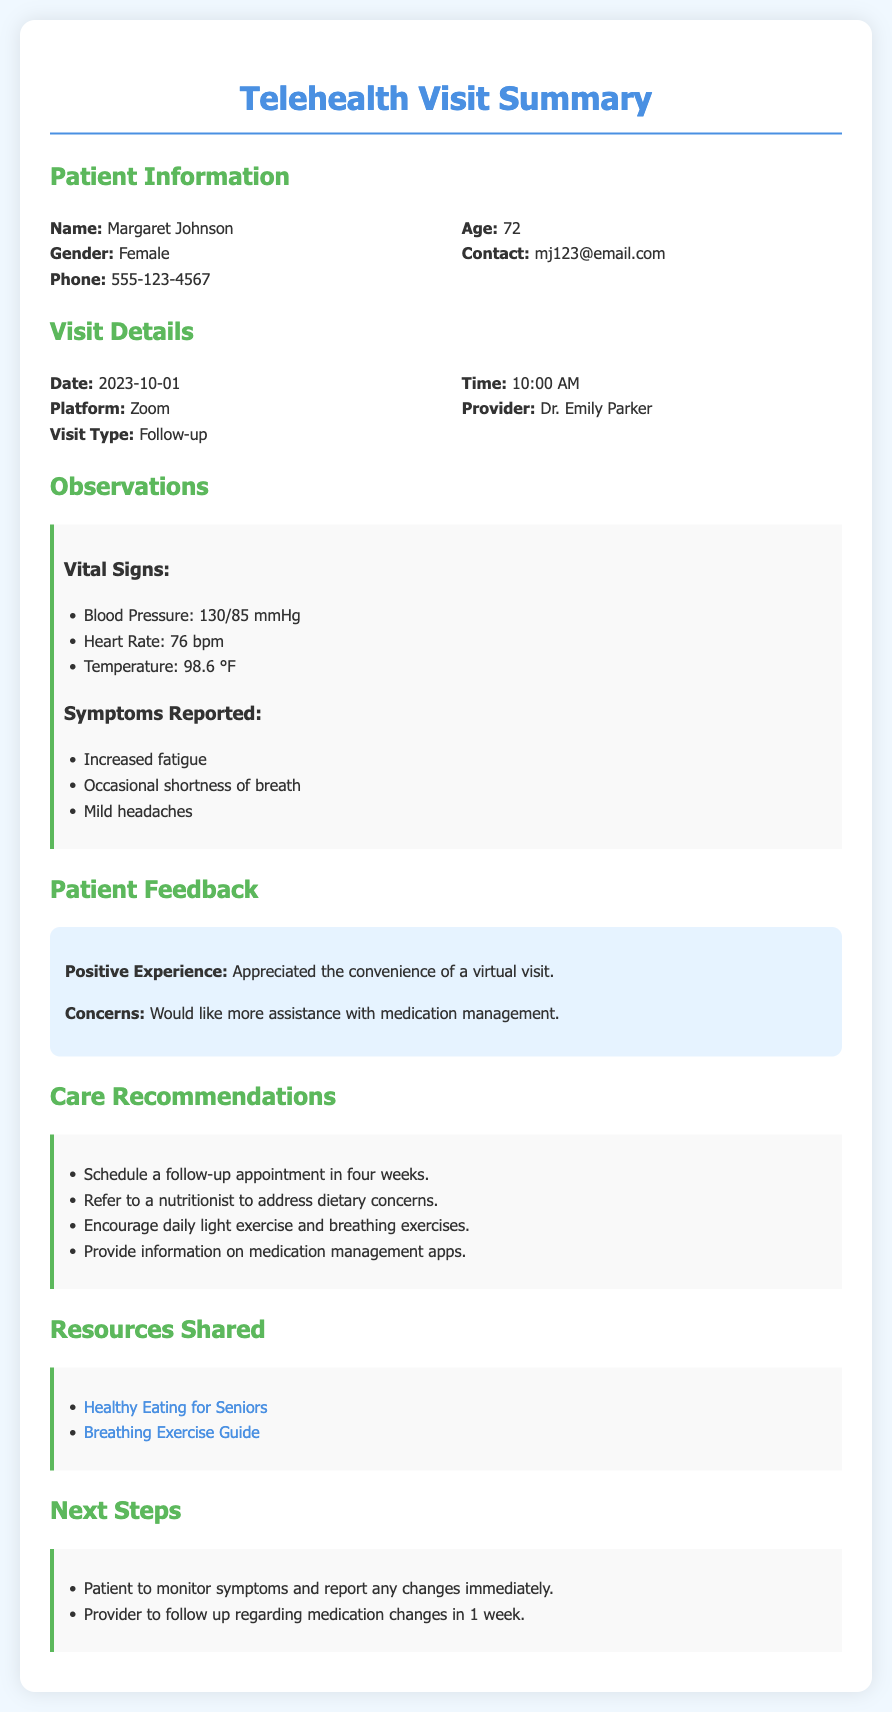What is the patient's name? The patient's name is mentioned in the Patient Information section of the document.
Answer: Margaret Johnson What is the patient's age? The age of the patient is specified in the Patient Information section.
Answer: 72 What was the date of the telehealth visit? The date is listed under Visit Details in the document.
Answer: 2023-10-01 What symptoms were reported by the patient? The symptoms are detailed in the Observations section of the document.
Answer: Increased fatigue, occasional shortness of breath, mild headaches How many weeks until the next follow-up appointment? The number of weeks is indicated in the Care Recommendations section.
Answer: Four What platform was used for the visit? The platform for the telehealth visit is mentioned in the Visit Details section.
Answer: Zoom What was a concern expressed by the patient? The patient's concern is noted in the Patient Feedback section.
Answer: More assistance with medication management What recommendation is given for exercise? Exercise recommendations are provided in the Care Recommendations section.
Answer: Daily light exercise and breathing exercises Which healthcare professional provided the visit? The provider's name can be found in the Visit Details section.
Answer: Dr. Emily Parker 